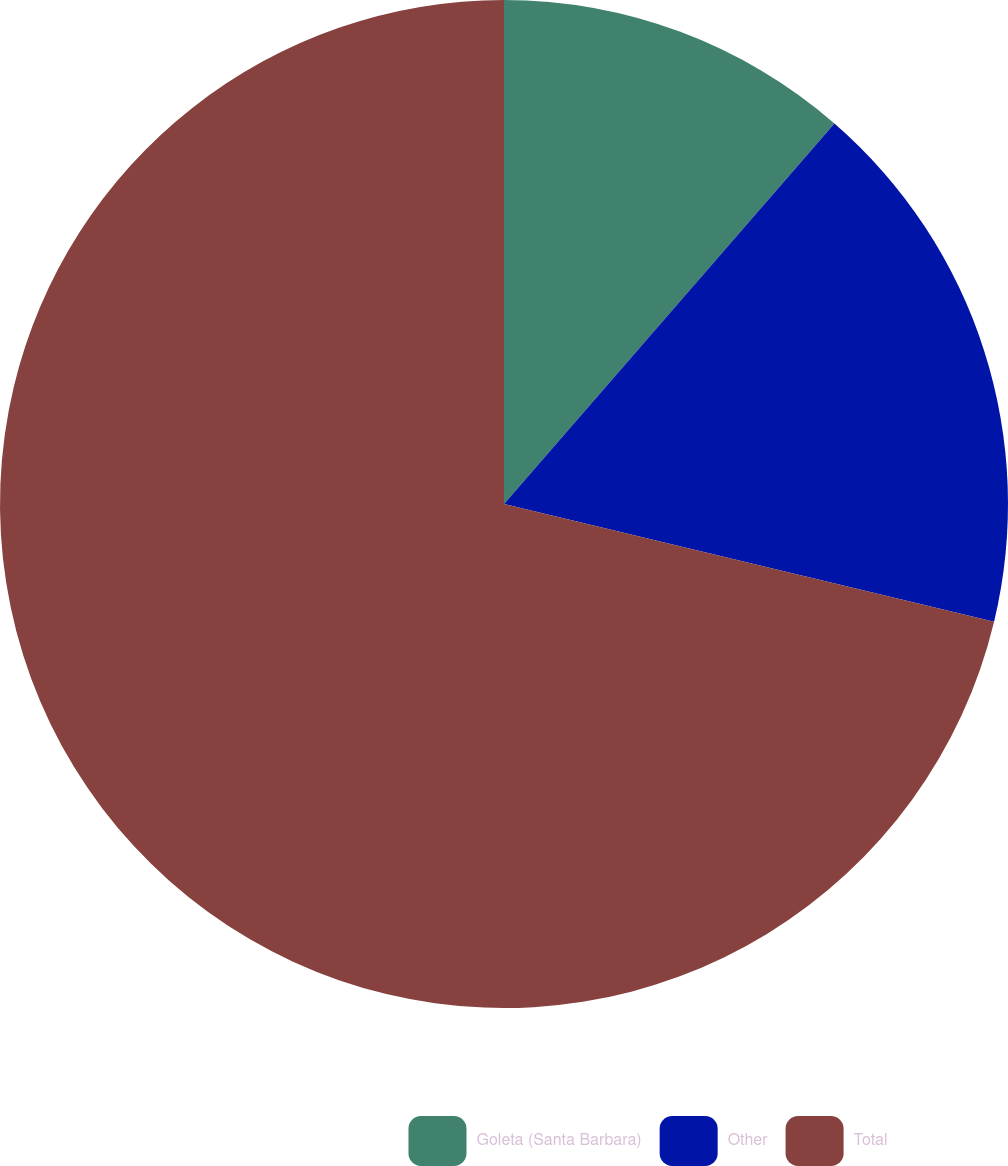Convert chart to OTSL. <chart><loc_0><loc_0><loc_500><loc_500><pie_chart><fcel>Goleta (Santa Barbara)<fcel>Other<fcel>Total<nl><fcel>11.38%<fcel>17.37%<fcel>71.25%<nl></chart> 